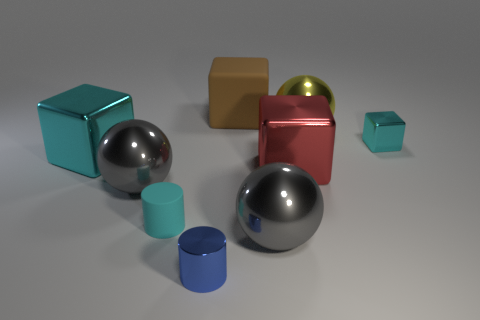What number of cylinders are there?
Give a very brief answer. 2. What number of spheres are either brown things or large cyan things?
Offer a very short reply. 0. How many blue metallic cylinders are behind the rubber thing that is left of the object that is behind the big yellow ball?
Give a very brief answer. 0. What is the color of the metallic cube that is the same size as the rubber cylinder?
Your answer should be compact. Cyan. What number of other things are there of the same color as the metal cylinder?
Your response must be concise. 0. Is the number of metallic blocks on the left side of the big yellow thing greater than the number of large rubber objects?
Give a very brief answer. Yes. Do the brown thing and the red object have the same material?
Keep it short and to the point. No. How many objects are blocks that are behind the small cyan shiny block or tiny blue cylinders?
Your answer should be very brief. 2. How many other objects are the same size as the cyan rubber thing?
Ensure brevity in your answer.  2. Are there the same number of cyan blocks that are in front of the shiny cylinder and big brown blocks that are behind the rubber block?
Your answer should be compact. Yes. 